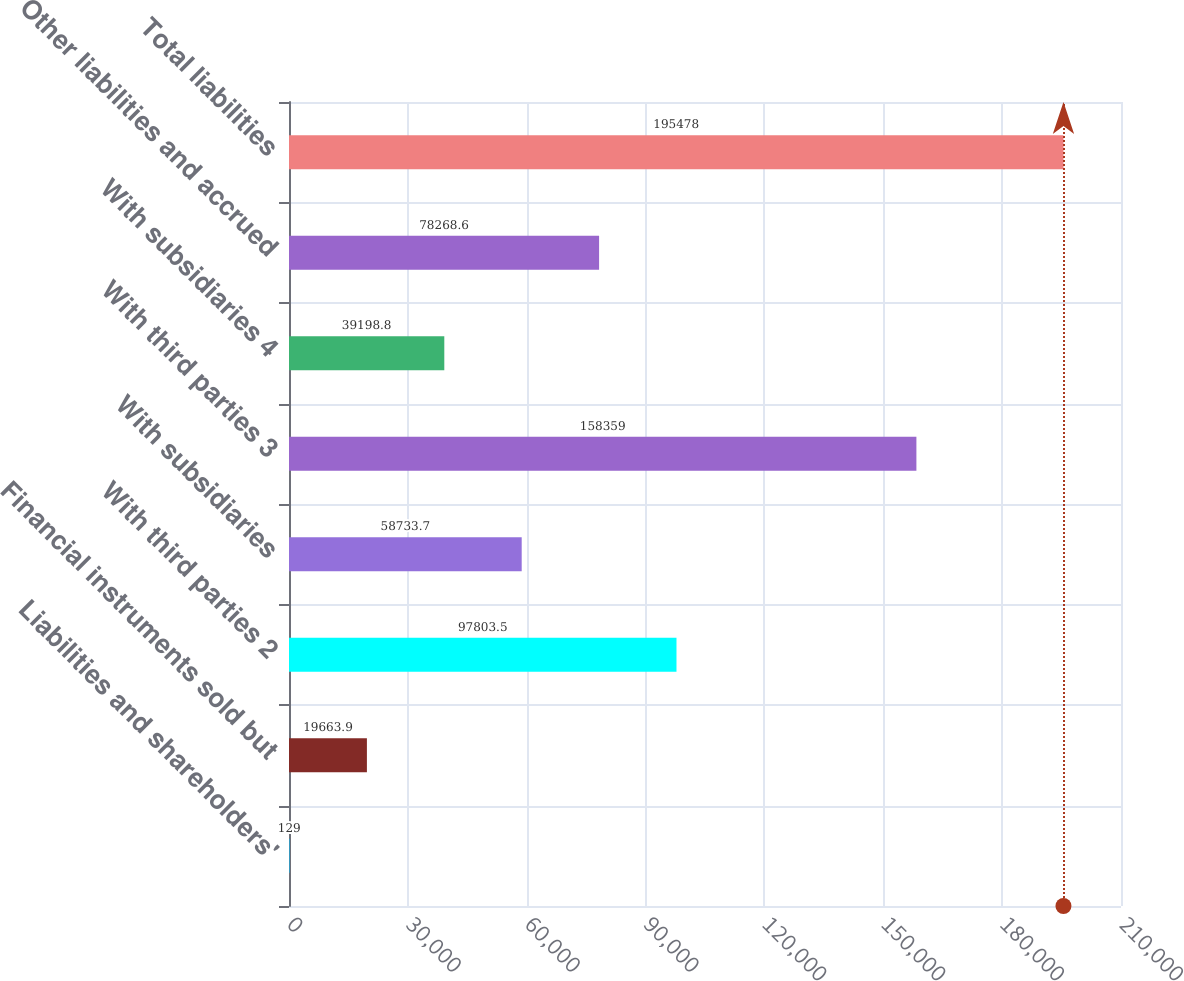Convert chart. <chart><loc_0><loc_0><loc_500><loc_500><bar_chart><fcel>Liabilities and shareholders'<fcel>Financial instruments sold but<fcel>With third parties 2<fcel>With subsidiaries<fcel>With third parties 3<fcel>With subsidiaries 4<fcel>Other liabilities and accrued<fcel>Total liabilities<nl><fcel>129<fcel>19663.9<fcel>97803.5<fcel>58733.7<fcel>158359<fcel>39198.8<fcel>78268.6<fcel>195478<nl></chart> 